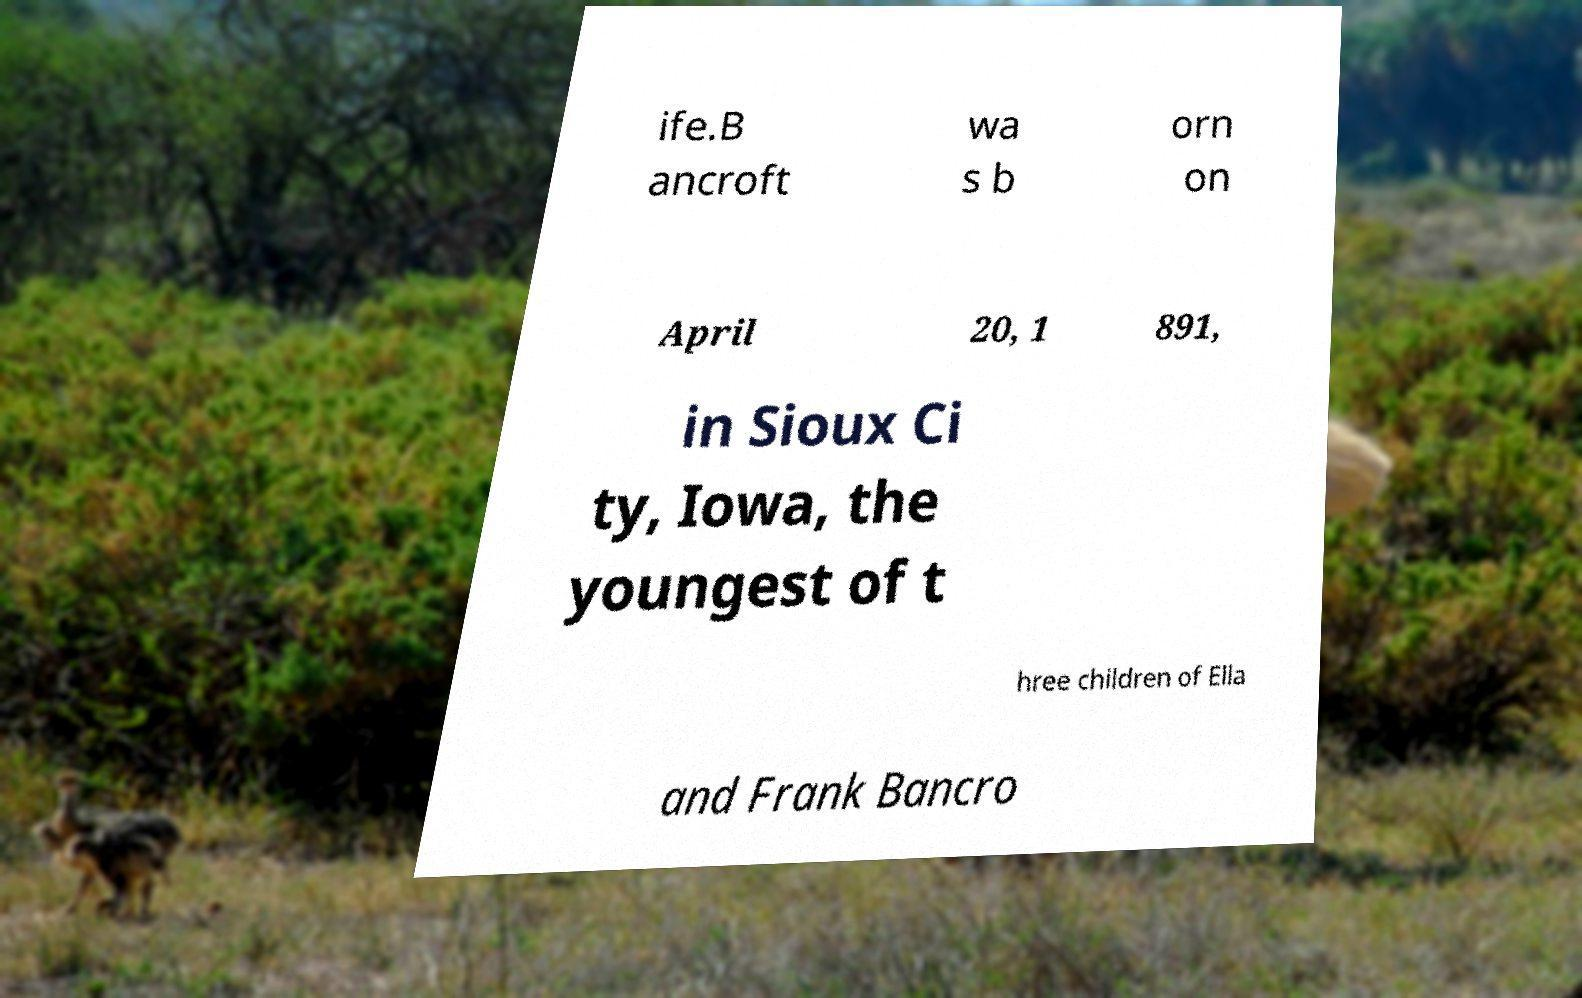Could you assist in decoding the text presented in this image and type it out clearly? ife.B ancroft wa s b orn on April 20, 1 891, in Sioux Ci ty, Iowa, the youngest of t hree children of Ella and Frank Bancro 